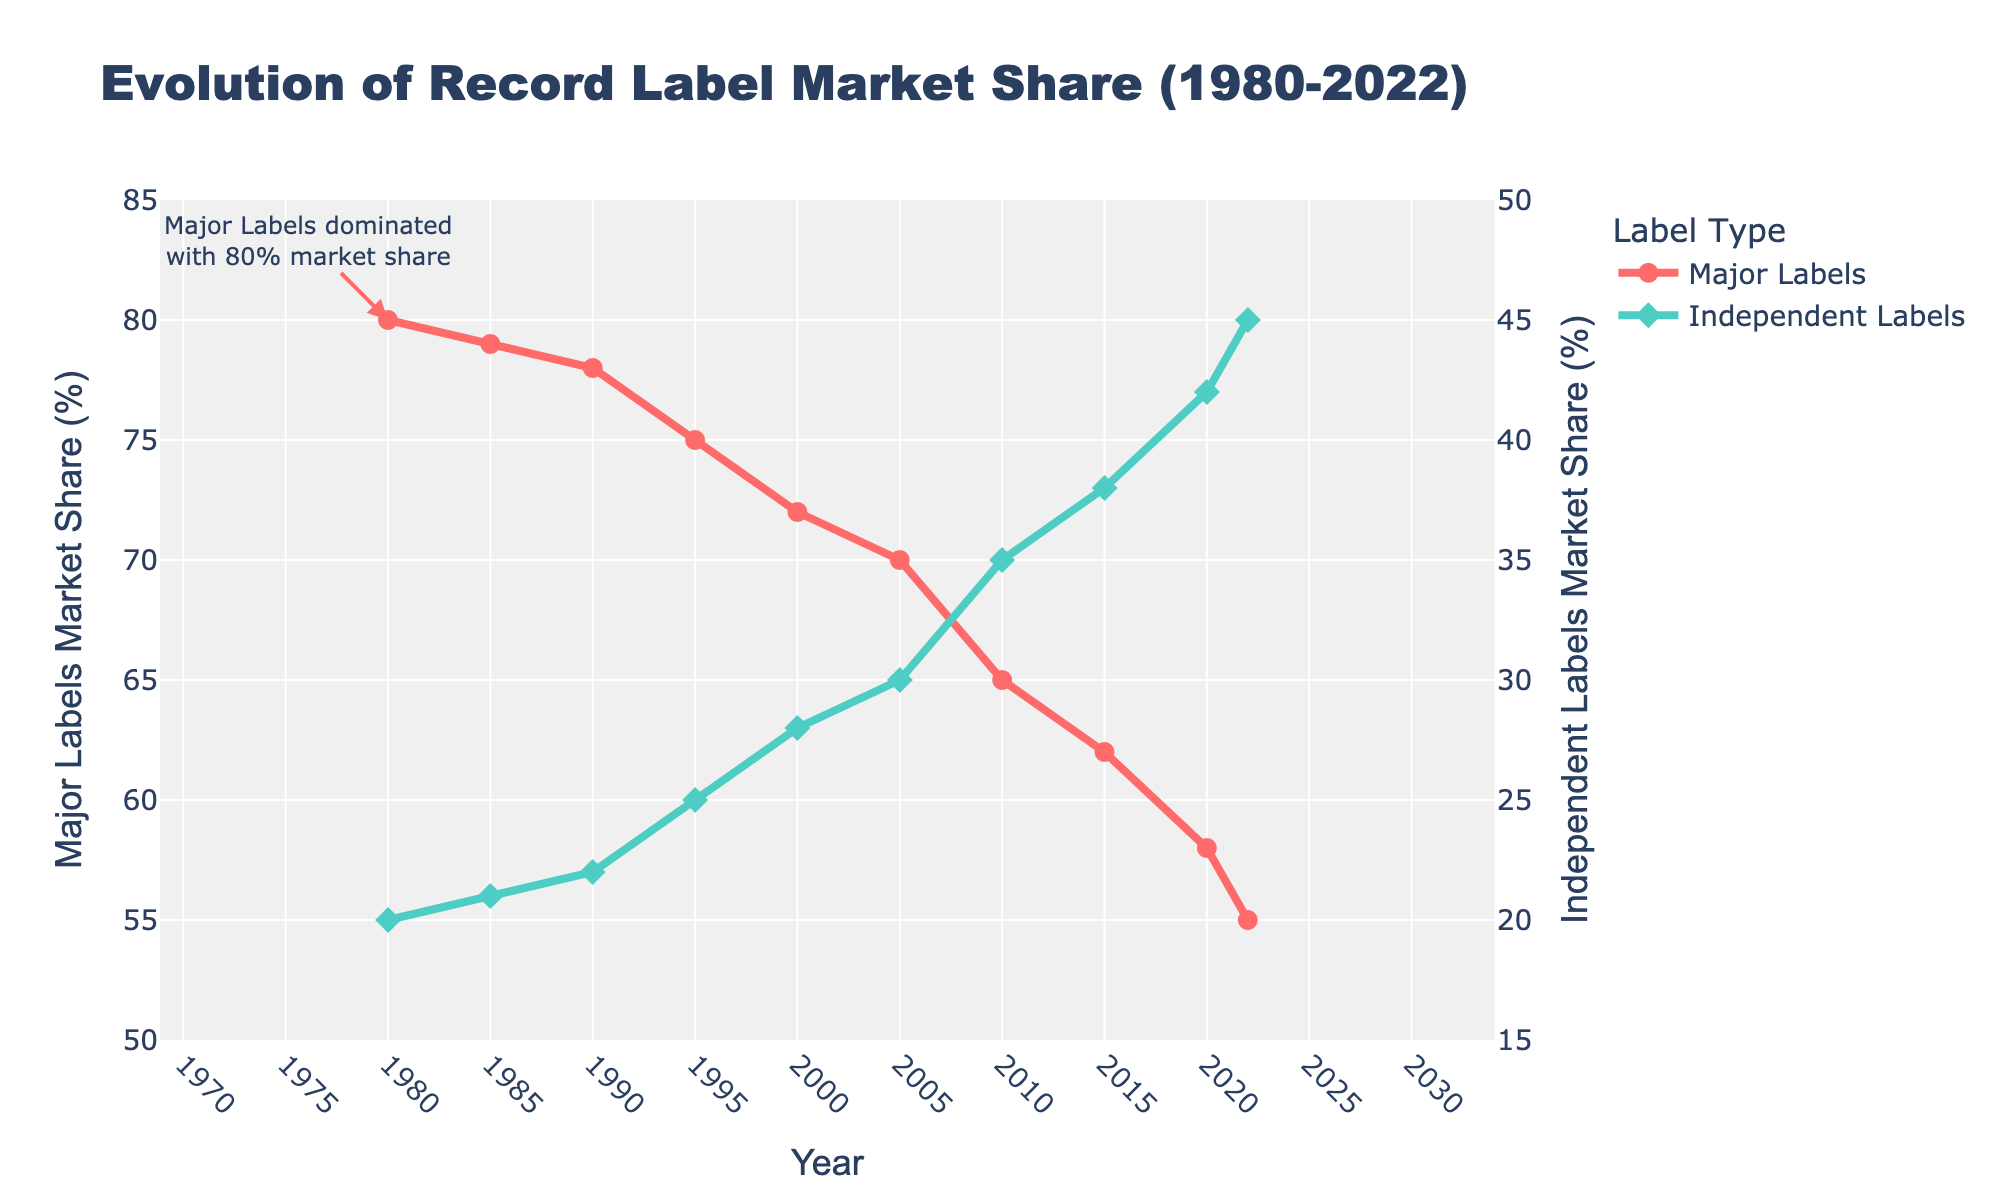How has the market share of Major Labels changed from 1980 to 2022? To find the change in market share of Major Labels from 1980 to 2022, locate the percentage values for Major Labels in 1980 (80%) and 2022 (55%) on the y-axis. Subtract the 2022 value from the 1980 value: 80% - 55% = 25%.
Answer: Decreased by 25% How does the market share of Independent Labels in 2022 compare to that in 2000? To compare the market share of Independent Labels in 2022 (45%) with 2000 (28%), refer to the y-axis values at these years. Note that 45% is greater than 28%, showing an increase. Subtract the 2000 value from the 2022 value: 45% - 28% = 17%.
Answer: Increased by 17% What was the market share difference between Major Labels and Independent Labels in 2010? To determine the difference in market share between Major Labels (65%) and Independent Labels (35%) in 2010, subtract the Independent Labels value from the Major Labels value: 65% - 35% = 30%.
Answer: 30% In which year did Independent Labels first reach a market share of 30% or more? To answer this, find the year when the Independent Labels market share value first hits or exceeds 30%. The chart shows Independent Labels reach a 30% market share in 2005 and not before.
Answer: 2005 What is the average market share of Independent Labels from 1980 to 2022? Calculate the average by adding the market share values of Independent Labels from 1980 (20%) to 2022 (45%) and dividing by the number of data points: (20+21+22+25+28+30+35+38+42+45)/10 = 30.6%.
Answer: 30.6% Between which consecutive years did Independent Labels experience the greatest increase in market share? Compare the annual increases in the market share of Independent Labels. The greatest increase is noticed between 2000 (28%) and 2005 (30%), which is an increase of 7% (25% to 35%). Other increases are smaller.
Answer: 2000 to 2005 How much larger was the market share of Major Labels compared to Independent Labels in 1985? Refer to the market share values in 1985 for Major Labels (79%) and Independent Labels (21%). The difference is: 79% - 21% = 58%.
Answer: 58% What color represents the Major Labels' market share line in the chart? Identify the color of the line representing Major Labels. The chart uses red to depict Major Labels' market share.
Answer: Red What was the year when Major Labels had a market share of less than 60% for the first time? Locate the year when Major Labels' market share first falls below 60%. The graph shows this occurred in 2020 with a market share of 58%.
Answer: 2020 By how much did the combined market share of both Major and Independent Labels change from 1980 to 2022? To find the combined market share change: Major Labels 80% + Independent Labels 20% = 100% in 1980 and Major Labels 55% + Independent Labels 45% = 100% in 2022. The combined market share remained constant at 100%.
Answer: No change 